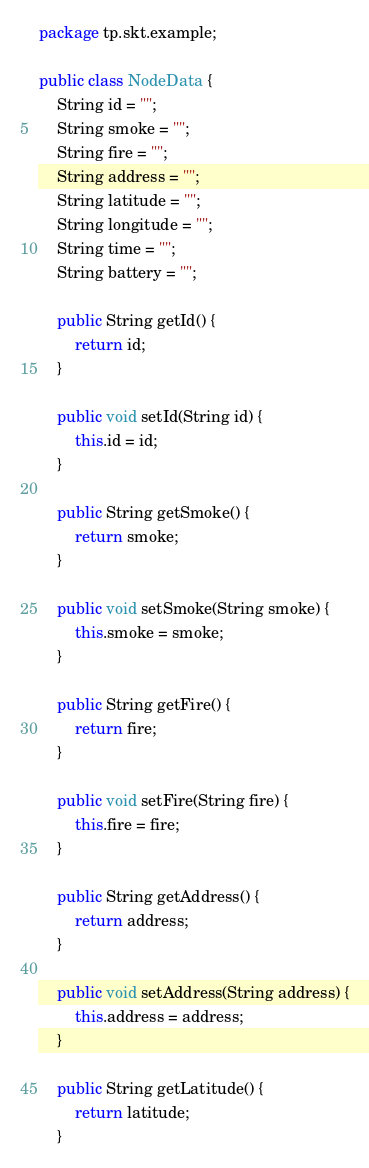Convert code to text. <code><loc_0><loc_0><loc_500><loc_500><_Java_>package tp.skt.example;

public class NodeData {
    String id = "";
    String smoke = "";
    String fire = "";
    String address = "";
    String latitude = "";
    String longitude = "";
    String time = "";
    String battery = "";

    public String getId() {
        return id;
    }

    public void setId(String id) {
        this.id = id;
    }

    public String getSmoke() {
        return smoke;
    }

    public void setSmoke(String smoke) {
        this.smoke = smoke;
    }

    public String getFire() {
        return fire;
    }

    public void setFire(String fire) {
        this.fire = fire;
    }

    public String getAddress() {
        return address;
    }

    public void setAddress(String address) {
        this.address = address;
    }

    public String getLatitude() {
        return latitude;
    }
</code> 